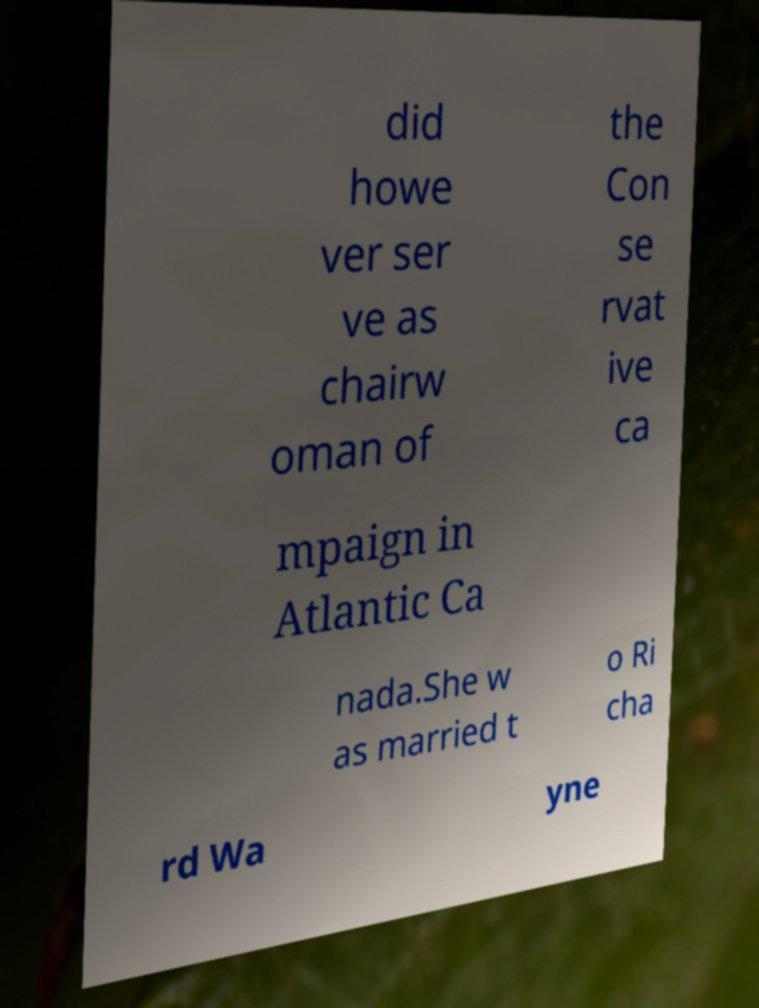Could you extract and type out the text from this image? did howe ver ser ve as chairw oman of the Con se rvat ive ca mpaign in Atlantic Ca nada.She w as married t o Ri cha rd Wa yne 